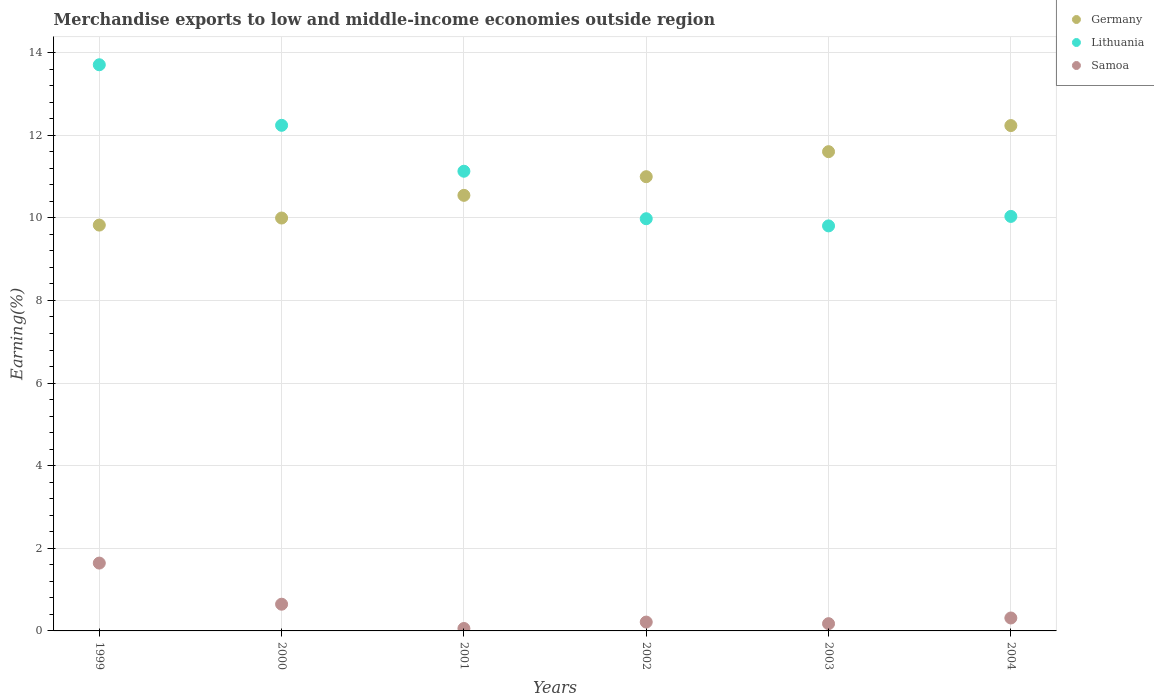How many different coloured dotlines are there?
Offer a terse response. 3. Is the number of dotlines equal to the number of legend labels?
Your response must be concise. Yes. What is the percentage of amount earned from merchandise exports in Samoa in 2000?
Give a very brief answer. 0.65. Across all years, what is the maximum percentage of amount earned from merchandise exports in Samoa?
Give a very brief answer. 1.64. Across all years, what is the minimum percentage of amount earned from merchandise exports in Lithuania?
Your answer should be very brief. 9.8. In which year was the percentage of amount earned from merchandise exports in Samoa maximum?
Give a very brief answer. 1999. In which year was the percentage of amount earned from merchandise exports in Germany minimum?
Provide a succinct answer. 1999. What is the total percentage of amount earned from merchandise exports in Germany in the graph?
Offer a terse response. 65.19. What is the difference between the percentage of amount earned from merchandise exports in Samoa in 2001 and that in 2003?
Your answer should be compact. -0.12. What is the difference between the percentage of amount earned from merchandise exports in Germany in 2002 and the percentage of amount earned from merchandise exports in Samoa in 2001?
Provide a short and direct response. 10.94. What is the average percentage of amount earned from merchandise exports in Samoa per year?
Provide a short and direct response. 0.51. In the year 1999, what is the difference between the percentage of amount earned from merchandise exports in Germany and percentage of amount earned from merchandise exports in Lithuania?
Make the answer very short. -3.88. What is the ratio of the percentage of amount earned from merchandise exports in Samoa in 2003 to that in 2004?
Provide a succinct answer. 0.56. Is the percentage of amount earned from merchandise exports in Germany in 2001 less than that in 2002?
Your answer should be very brief. Yes. Is the difference between the percentage of amount earned from merchandise exports in Germany in 1999 and 2000 greater than the difference between the percentage of amount earned from merchandise exports in Lithuania in 1999 and 2000?
Give a very brief answer. No. What is the difference between the highest and the second highest percentage of amount earned from merchandise exports in Samoa?
Offer a very short reply. 1. What is the difference between the highest and the lowest percentage of amount earned from merchandise exports in Samoa?
Keep it short and to the point. 1.58. In how many years, is the percentage of amount earned from merchandise exports in Lithuania greater than the average percentage of amount earned from merchandise exports in Lithuania taken over all years?
Your answer should be very brief. 2. Is the sum of the percentage of amount earned from merchandise exports in Germany in 1999 and 2004 greater than the maximum percentage of amount earned from merchandise exports in Lithuania across all years?
Provide a short and direct response. Yes. What is the difference between two consecutive major ticks on the Y-axis?
Ensure brevity in your answer.  2. Are the values on the major ticks of Y-axis written in scientific E-notation?
Ensure brevity in your answer.  No. Does the graph contain grids?
Offer a very short reply. Yes. Where does the legend appear in the graph?
Offer a terse response. Top right. How many legend labels are there?
Keep it short and to the point. 3. What is the title of the graph?
Offer a terse response. Merchandise exports to low and middle-income economies outside region. Does "Oman" appear as one of the legend labels in the graph?
Your answer should be very brief. No. What is the label or title of the Y-axis?
Your answer should be compact. Earning(%). What is the Earning(%) in Germany in 1999?
Keep it short and to the point. 9.82. What is the Earning(%) of Lithuania in 1999?
Offer a terse response. 13.71. What is the Earning(%) in Samoa in 1999?
Keep it short and to the point. 1.64. What is the Earning(%) of Germany in 2000?
Your answer should be very brief. 10. What is the Earning(%) in Lithuania in 2000?
Keep it short and to the point. 12.24. What is the Earning(%) of Samoa in 2000?
Your answer should be very brief. 0.65. What is the Earning(%) of Germany in 2001?
Offer a terse response. 10.54. What is the Earning(%) of Lithuania in 2001?
Your answer should be compact. 11.13. What is the Earning(%) in Samoa in 2001?
Make the answer very short. 0.06. What is the Earning(%) of Germany in 2002?
Your answer should be very brief. 11. What is the Earning(%) in Lithuania in 2002?
Offer a very short reply. 9.98. What is the Earning(%) in Samoa in 2002?
Make the answer very short. 0.21. What is the Earning(%) in Germany in 2003?
Offer a very short reply. 11.6. What is the Earning(%) of Lithuania in 2003?
Offer a very short reply. 9.8. What is the Earning(%) in Samoa in 2003?
Your answer should be compact. 0.18. What is the Earning(%) in Germany in 2004?
Provide a succinct answer. 12.23. What is the Earning(%) of Lithuania in 2004?
Ensure brevity in your answer.  10.03. What is the Earning(%) of Samoa in 2004?
Ensure brevity in your answer.  0.31. Across all years, what is the maximum Earning(%) of Germany?
Offer a terse response. 12.23. Across all years, what is the maximum Earning(%) of Lithuania?
Offer a very short reply. 13.71. Across all years, what is the maximum Earning(%) of Samoa?
Make the answer very short. 1.64. Across all years, what is the minimum Earning(%) in Germany?
Your answer should be very brief. 9.82. Across all years, what is the minimum Earning(%) of Lithuania?
Provide a short and direct response. 9.8. Across all years, what is the minimum Earning(%) of Samoa?
Ensure brevity in your answer.  0.06. What is the total Earning(%) in Germany in the graph?
Provide a short and direct response. 65.19. What is the total Earning(%) of Lithuania in the graph?
Keep it short and to the point. 66.89. What is the total Earning(%) in Samoa in the graph?
Make the answer very short. 3.05. What is the difference between the Earning(%) of Germany in 1999 and that in 2000?
Give a very brief answer. -0.17. What is the difference between the Earning(%) of Lithuania in 1999 and that in 2000?
Make the answer very short. 1.47. What is the difference between the Earning(%) in Samoa in 1999 and that in 2000?
Your response must be concise. 1. What is the difference between the Earning(%) in Germany in 1999 and that in 2001?
Your response must be concise. -0.72. What is the difference between the Earning(%) of Lithuania in 1999 and that in 2001?
Give a very brief answer. 2.58. What is the difference between the Earning(%) of Samoa in 1999 and that in 2001?
Your answer should be very brief. 1.58. What is the difference between the Earning(%) in Germany in 1999 and that in 2002?
Your answer should be compact. -1.17. What is the difference between the Earning(%) in Lithuania in 1999 and that in 2002?
Your response must be concise. 3.73. What is the difference between the Earning(%) of Samoa in 1999 and that in 2002?
Give a very brief answer. 1.43. What is the difference between the Earning(%) in Germany in 1999 and that in 2003?
Your answer should be very brief. -1.78. What is the difference between the Earning(%) in Lithuania in 1999 and that in 2003?
Your answer should be compact. 3.9. What is the difference between the Earning(%) in Samoa in 1999 and that in 2003?
Provide a succinct answer. 1.47. What is the difference between the Earning(%) in Germany in 1999 and that in 2004?
Provide a succinct answer. -2.41. What is the difference between the Earning(%) in Lithuania in 1999 and that in 2004?
Offer a terse response. 3.67. What is the difference between the Earning(%) in Samoa in 1999 and that in 2004?
Your answer should be compact. 1.33. What is the difference between the Earning(%) in Germany in 2000 and that in 2001?
Make the answer very short. -0.55. What is the difference between the Earning(%) in Lithuania in 2000 and that in 2001?
Offer a terse response. 1.11. What is the difference between the Earning(%) of Samoa in 2000 and that in 2001?
Keep it short and to the point. 0.59. What is the difference between the Earning(%) of Germany in 2000 and that in 2002?
Offer a very short reply. -1. What is the difference between the Earning(%) in Lithuania in 2000 and that in 2002?
Your answer should be very brief. 2.26. What is the difference between the Earning(%) in Samoa in 2000 and that in 2002?
Make the answer very short. 0.43. What is the difference between the Earning(%) in Germany in 2000 and that in 2003?
Offer a terse response. -1.61. What is the difference between the Earning(%) of Lithuania in 2000 and that in 2003?
Your response must be concise. 2.43. What is the difference between the Earning(%) of Samoa in 2000 and that in 2003?
Offer a terse response. 0.47. What is the difference between the Earning(%) of Germany in 2000 and that in 2004?
Make the answer very short. -2.24. What is the difference between the Earning(%) in Lithuania in 2000 and that in 2004?
Make the answer very short. 2.21. What is the difference between the Earning(%) of Samoa in 2000 and that in 2004?
Offer a very short reply. 0.33. What is the difference between the Earning(%) in Germany in 2001 and that in 2002?
Your response must be concise. -0.45. What is the difference between the Earning(%) of Lithuania in 2001 and that in 2002?
Your answer should be very brief. 1.15. What is the difference between the Earning(%) of Samoa in 2001 and that in 2002?
Your answer should be compact. -0.15. What is the difference between the Earning(%) of Germany in 2001 and that in 2003?
Give a very brief answer. -1.06. What is the difference between the Earning(%) of Lithuania in 2001 and that in 2003?
Provide a succinct answer. 1.32. What is the difference between the Earning(%) of Samoa in 2001 and that in 2003?
Provide a short and direct response. -0.12. What is the difference between the Earning(%) of Germany in 2001 and that in 2004?
Offer a very short reply. -1.69. What is the difference between the Earning(%) in Lithuania in 2001 and that in 2004?
Give a very brief answer. 1.09. What is the difference between the Earning(%) of Samoa in 2001 and that in 2004?
Provide a short and direct response. -0.25. What is the difference between the Earning(%) in Germany in 2002 and that in 2003?
Provide a succinct answer. -0.61. What is the difference between the Earning(%) in Lithuania in 2002 and that in 2003?
Provide a short and direct response. 0.17. What is the difference between the Earning(%) in Samoa in 2002 and that in 2003?
Give a very brief answer. 0.04. What is the difference between the Earning(%) of Germany in 2002 and that in 2004?
Your answer should be very brief. -1.24. What is the difference between the Earning(%) in Lithuania in 2002 and that in 2004?
Your answer should be very brief. -0.06. What is the difference between the Earning(%) of Samoa in 2002 and that in 2004?
Your answer should be very brief. -0.1. What is the difference between the Earning(%) in Germany in 2003 and that in 2004?
Your answer should be very brief. -0.63. What is the difference between the Earning(%) of Lithuania in 2003 and that in 2004?
Provide a short and direct response. -0.23. What is the difference between the Earning(%) of Samoa in 2003 and that in 2004?
Give a very brief answer. -0.14. What is the difference between the Earning(%) of Germany in 1999 and the Earning(%) of Lithuania in 2000?
Your answer should be very brief. -2.42. What is the difference between the Earning(%) in Germany in 1999 and the Earning(%) in Samoa in 2000?
Your response must be concise. 9.18. What is the difference between the Earning(%) of Lithuania in 1999 and the Earning(%) of Samoa in 2000?
Keep it short and to the point. 13.06. What is the difference between the Earning(%) of Germany in 1999 and the Earning(%) of Lithuania in 2001?
Make the answer very short. -1.3. What is the difference between the Earning(%) of Germany in 1999 and the Earning(%) of Samoa in 2001?
Make the answer very short. 9.77. What is the difference between the Earning(%) in Lithuania in 1999 and the Earning(%) in Samoa in 2001?
Offer a very short reply. 13.65. What is the difference between the Earning(%) in Germany in 1999 and the Earning(%) in Lithuania in 2002?
Ensure brevity in your answer.  -0.15. What is the difference between the Earning(%) of Germany in 1999 and the Earning(%) of Samoa in 2002?
Your response must be concise. 9.61. What is the difference between the Earning(%) of Lithuania in 1999 and the Earning(%) of Samoa in 2002?
Keep it short and to the point. 13.49. What is the difference between the Earning(%) of Germany in 1999 and the Earning(%) of Lithuania in 2003?
Ensure brevity in your answer.  0.02. What is the difference between the Earning(%) in Germany in 1999 and the Earning(%) in Samoa in 2003?
Your response must be concise. 9.65. What is the difference between the Earning(%) in Lithuania in 1999 and the Earning(%) in Samoa in 2003?
Provide a succinct answer. 13.53. What is the difference between the Earning(%) of Germany in 1999 and the Earning(%) of Lithuania in 2004?
Your response must be concise. -0.21. What is the difference between the Earning(%) of Germany in 1999 and the Earning(%) of Samoa in 2004?
Your answer should be compact. 9.51. What is the difference between the Earning(%) in Lithuania in 1999 and the Earning(%) in Samoa in 2004?
Your answer should be very brief. 13.39. What is the difference between the Earning(%) in Germany in 2000 and the Earning(%) in Lithuania in 2001?
Provide a succinct answer. -1.13. What is the difference between the Earning(%) of Germany in 2000 and the Earning(%) of Samoa in 2001?
Your response must be concise. 9.94. What is the difference between the Earning(%) of Lithuania in 2000 and the Earning(%) of Samoa in 2001?
Offer a terse response. 12.18. What is the difference between the Earning(%) of Germany in 2000 and the Earning(%) of Lithuania in 2002?
Give a very brief answer. 0.02. What is the difference between the Earning(%) in Germany in 2000 and the Earning(%) in Samoa in 2002?
Keep it short and to the point. 9.78. What is the difference between the Earning(%) of Lithuania in 2000 and the Earning(%) of Samoa in 2002?
Your response must be concise. 12.03. What is the difference between the Earning(%) in Germany in 2000 and the Earning(%) in Lithuania in 2003?
Keep it short and to the point. 0.19. What is the difference between the Earning(%) of Germany in 2000 and the Earning(%) of Samoa in 2003?
Keep it short and to the point. 9.82. What is the difference between the Earning(%) of Lithuania in 2000 and the Earning(%) of Samoa in 2003?
Provide a short and direct response. 12.06. What is the difference between the Earning(%) in Germany in 2000 and the Earning(%) in Lithuania in 2004?
Your response must be concise. -0.04. What is the difference between the Earning(%) of Germany in 2000 and the Earning(%) of Samoa in 2004?
Provide a succinct answer. 9.68. What is the difference between the Earning(%) in Lithuania in 2000 and the Earning(%) in Samoa in 2004?
Keep it short and to the point. 11.93. What is the difference between the Earning(%) in Germany in 2001 and the Earning(%) in Lithuania in 2002?
Your answer should be compact. 0.57. What is the difference between the Earning(%) in Germany in 2001 and the Earning(%) in Samoa in 2002?
Provide a succinct answer. 10.33. What is the difference between the Earning(%) of Lithuania in 2001 and the Earning(%) of Samoa in 2002?
Ensure brevity in your answer.  10.91. What is the difference between the Earning(%) in Germany in 2001 and the Earning(%) in Lithuania in 2003?
Keep it short and to the point. 0.74. What is the difference between the Earning(%) of Germany in 2001 and the Earning(%) of Samoa in 2003?
Offer a very short reply. 10.37. What is the difference between the Earning(%) of Lithuania in 2001 and the Earning(%) of Samoa in 2003?
Ensure brevity in your answer.  10.95. What is the difference between the Earning(%) in Germany in 2001 and the Earning(%) in Lithuania in 2004?
Your response must be concise. 0.51. What is the difference between the Earning(%) in Germany in 2001 and the Earning(%) in Samoa in 2004?
Your response must be concise. 10.23. What is the difference between the Earning(%) in Lithuania in 2001 and the Earning(%) in Samoa in 2004?
Your answer should be compact. 10.81. What is the difference between the Earning(%) in Germany in 2002 and the Earning(%) in Lithuania in 2003?
Provide a succinct answer. 1.19. What is the difference between the Earning(%) of Germany in 2002 and the Earning(%) of Samoa in 2003?
Ensure brevity in your answer.  10.82. What is the difference between the Earning(%) in Lithuania in 2002 and the Earning(%) in Samoa in 2003?
Give a very brief answer. 9.8. What is the difference between the Earning(%) in Germany in 2002 and the Earning(%) in Lithuania in 2004?
Provide a succinct answer. 0.96. What is the difference between the Earning(%) of Germany in 2002 and the Earning(%) of Samoa in 2004?
Provide a short and direct response. 10.68. What is the difference between the Earning(%) in Lithuania in 2002 and the Earning(%) in Samoa in 2004?
Provide a succinct answer. 9.67. What is the difference between the Earning(%) of Germany in 2003 and the Earning(%) of Lithuania in 2004?
Offer a very short reply. 1.57. What is the difference between the Earning(%) of Germany in 2003 and the Earning(%) of Samoa in 2004?
Keep it short and to the point. 11.29. What is the difference between the Earning(%) of Lithuania in 2003 and the Earning(%) of Samoa in 2004?
Ensure brevity in your answer.  9.49. What is the average Earning(%) in Germany per year?
Provide a succinct answer. 10.87. What is the average Earning(%) in Lithuania per year?
Your response must be concise. 11.15. What is the average Earning(%) in Samoa per year?
Make the answer very short. 0.51. In the year 1999, what is the difference between the Earning(%) of Germany and Earning(%) of Lithuania?
Offer a terse response. -3.88. In the year 1999, what is the difference between the Earning(%) of Germany and Earning(%) of Samoa?
Give a very brief answer. 8.18. In the year 1999, what is the difference between the Earning(%) in Lithuania and Earning(%) in Samoa?
Keep it short and to the point. 12.06. In the year 2000, what is the difference between the Earning(%) in Germany and Earning(%) in Lithuania?
Ensure brevity in your answer.  -2.24. In the year 2000, what is the difference between the Earning(%) in Germany and Earning(%) in Samoa?
Make the answer very short. 9.35. In the year 2000, what is the difference between the Earning(%) in Lithuania and Earning(%) in Samoa?
Make the answer very short. 11.59. In the year 2001, what is the difference between the Earning(%) of Germany and Earning(%) of Lithuania?
Your response must be concise. -0.58. In the year 2001, what is the difference between the Earning(%) of Germany and Earning(%) of Samoa?
Give a very brief answer. 10.49. In the year 2001, what is the difference between the Earning(%) of Lithuania and Earning(%) of Samoa?
Offer a terse response. 11.07. In the year 2002, what is the difference between the Earning(%) of Germany and Earning(%) of Lithuania?
Provide a succinct answer. 1.02. In the year 2002, what is the difference between the Earning(%) of Germany and Earning(%) of Samoa?
Offer a terse response. 10.78. In the year 2002, what is the difference between the Earning(%) in Lithuania and Earning(%) in Samoa?
Your answer should be compact. 9.76. In the year 2003, what is the difference between the Earning(%) of Germany and Earning(%) of Lithuania?
Provide a succinct answer. 1.8. In the year 2003, what is the difference between the Earning(%) in Germany and Earning(%) in Samoa?
Your answer should be compact. 11.43. In the year 2003, what is the difference between the Earning(%) in Lithuania and Earning(%) in Samoa?
Give a very brief answer. 9.63. In the year 2004, what is the difference between the Earning(%) of Germany and Earning(%) of Lithuania?
Your answer should be compact. 2.2. In the year 2004, what is the difference between the Earning(%) of Germany and Earning(%) of Samoa?
Your answer should be compact. 11.92. In the year 2004, what is the difference between the Earning(%) of Lithuania and Earning(%) of Samoa?
Offer a very short reply. 9.72. What is the ratio of the Earning(%) in Germany in 1999 to that in 2000?
Offer a very short reply. 0.98. What is the ratio of the Earning(%) in Lithuania in 1999 to that in 2000?
Ensure brevity in your answer.  1.12. What is the ratio of the Earning(%) in Samoa in 1999 to that in 2000?
Keep it short and to the point. 2.54. What is the ratio of the Earning(%) of Germany in 1999 to that in 2001?
Provide a succinct answer. 0.93. What is the ratio of the Earning(%) of Lithuania in 1999 to that in 2001?
Your answer should be very brief. 1.23. What is the ratio of the Earning(%) of Samoa in 1999 to that in 2001?
Keep it short and to the point. 27.81. What is the ratio of the Earning(%) in Germany in 1999 to that in 2002?
Provide a succinct answer. 0.89. What is the ratio of the Earning(%) of Lithuania in 1999 to that in 2002?
Offer a very short reply. 1.37. What is the ratio of the Earning(%) of Samoa in 1999 to that in 2002?
Your answer should be very brief. 7.67. What is the ratio of the Earning(%) in Germany in 1999 to that in 2003?
Your answer should be compact. 0.85. What is the ratio of the Earning(%) in Lithuania in 1999 to that in 2003?
Your response must be concise. 1.4. What is the ratio of the Earning(%) in Samoa in 1999 to that in 2003?
Your answer should be very brief. 9.36. What is the ratio of the Earning(%) of Germany in 1999 to that in 2004?
Offer a very short reply. 0.8. What is the ratio of the Earning(%) of Lithuania in 1999 to that in 2004?
Offer a very short reply. 1.37. What is the ratio of the Earning(%) of Samoa in 1999 to that in 2004?
Give a very brief answer. 5.24. What is the ratio of the Earning(%) of Germany in 2000 to that in 2001?
Provide a short and direct response. 0.95. What is the ratio of the Earning(%) in Lithuania in 2000 to that in 2001?
Ensure brevity in your answer.  1.1. What is the ratio of the Earning(%) in Samoa in 2000 to that in 2001?
Your answer should be very brief. 10.95. What is the ratio of the Earning(%) of Germany in 2000 to that in 2002?
Give a very brief answer. 0.91. What is the ratio of the Earning(%) of Lithuania in 2000 to that in 2002?
Offer a very short reply. 1.23. What is the ratio of the Earning(%) of Samoa in 2000 to that in 2002?
Provide a succinct answer. 3.02. What is the ratio of the Earning(%) of Germany in 2000 to that in 2003?
Offer a very short reply. 0.86. What is the ratio of the Earning(%) in Lithuania in 2000 to that in 2003?
Your response must be concise. 1.25. What is the ratio of the Earning(%) of Samoa in 2000 to that in 2003?
Offer a terse response. 3.68. What is the ratio of the Earning(%) of Germany in 2000 to that in 2004?
Make the answer very short. 0.82. What is the ratio of the Earning(%) of Lithuania in 2000 to that in 2004?
Offer a very short reply. 1.22. What is the ratio of the Earning(%) of Samoa in 2000 to that in 2004?
Your answer should be very brief. 2.07. What is the ratio of the Earning(%) of Germany in 2001 to that in 2002?
Give a very brief answer. 0.96. What is the ratio of the Earning(%) of Lithuania in 2001 to that in 2002?
Your answer should be very brief. 1.12. What is the ratio of the Earning(%) in Samoa in 2001 to that in 2002?
Make the answer very short. 0.28. What is the ratio of the Earning(%) of Germany in 2001 to that in 2003?
Offer a terse response. 0.91. What is the ratio of the Earning(%) of Lithuania in 2001 to that in 2003?
Keep it short and to the point. 1.13. What is the ratio of the Earning(%) in Samoa in 2001 to that in 2003?
Ensure brevity in your answer.  0.34. What is the ratio of the Earning(%) in Germany in 2001 to that in 2004?
Your response must be concise. 0.86. What is the ratio of the Earning(%) of Lithuania in 2001 to that in 2004?
Ensure brevity in your answer.  1.11. What is the ratio of the Earning(%) in Samoa in 2001 to that in 2004?
Keep it short and to the point. 0.19. What is the ratio of the Earning(%) in Germany in 2002 to that in 2003?
Provide a succinct answer. 0.95. What is the ratio of the Earning(%) in Lithuania in 2002 to that in 2003?
Your answer should be compact. 1.02. What is the ratio of the Earning(%) of Samoa in 2002 to that in 2003?
Keep it short and to the point. 1.22. What is the ratio of the Earning(%) in Germany in 2002 to that in 2004?
Offer a terse response. 0.9. What is the ratio of the Earning(%) in Lithuania in 2002 to that in 2004?
Make the answer very short. 0.99. What is the ratio of the Earning(%) in Samoa in 2002 to that in 2004?
Offer a terse response. 0.68. What is the ratio of the Earning(%) of Germany in 2003 to that in 2004?
Make the answer very short. 0.95. What is the ratio of the Earning(%) of Lithuania in 2003 to that in 2004?
Provide a succinct answer. 0.98. What is the ratio of the Earning(%) in Samoa in 2003 to that in 2004?
Give a very brief answer. 0.56. What is the difference between the highest and the second highest Earning(%) of Germany?
Offer a very short reply. 0.63. What is the difference between the highest and the second highest Earning(%) of Lithuania?
Provide a short and direct response. 1.47. What is the difference between the highest and the second highest Earning(%) of Samoa?
Offer a very short reply. 1. What is the difference between the highest and the lowest Earning(%) of Germany?
Make the answer very short. 2.41. What is the difference between the highest and the lowest Earning(%) of Lithuania?
Keep it short and to the point. 3.9. What is the difference between the highest and the lowest Earning(%) in Samoa?
Offer a terse response. 1.58. 